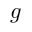<formula> <loc_0><loc_0><loc_500><loc_500>g</formula> 